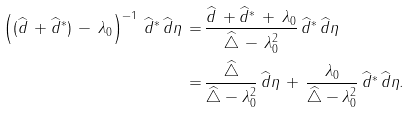<formula> <loc_0><loc_0><loc_500><loc_500>\left ( ( \widehat { d } \, + \widehat { d } ^ { * } ) \, - \, \lambda _ { 0 } \right ) ^ { - 1 } \, \widehat { d } ^ { * } \, \widehat { d } \eta \, = \, & \frac { \widehat { d } \, + \widehat { d } ^ { * } \, + \, \lambda _ { 0 } } { \widehat { \triangle } \, - \, \lambda _ { 0 } ^ { 2 } } \, \widehat { d } ^ { * } \, \widehat { d } \eta \\ = \, & \frac { \widehat { \triangle } } { \widehat { \triangle } - \lambda _ { 0 } ^ { 2 } } \, \widehat { d } \eta \, + \, \frac { \lambda _ { 0 } } { \widehat { \triangle } - \lambda _ { 0 } ^ { 2 } } \, \widehat { d } ^ { * } \, \widehat { d } \eta .</formula> 